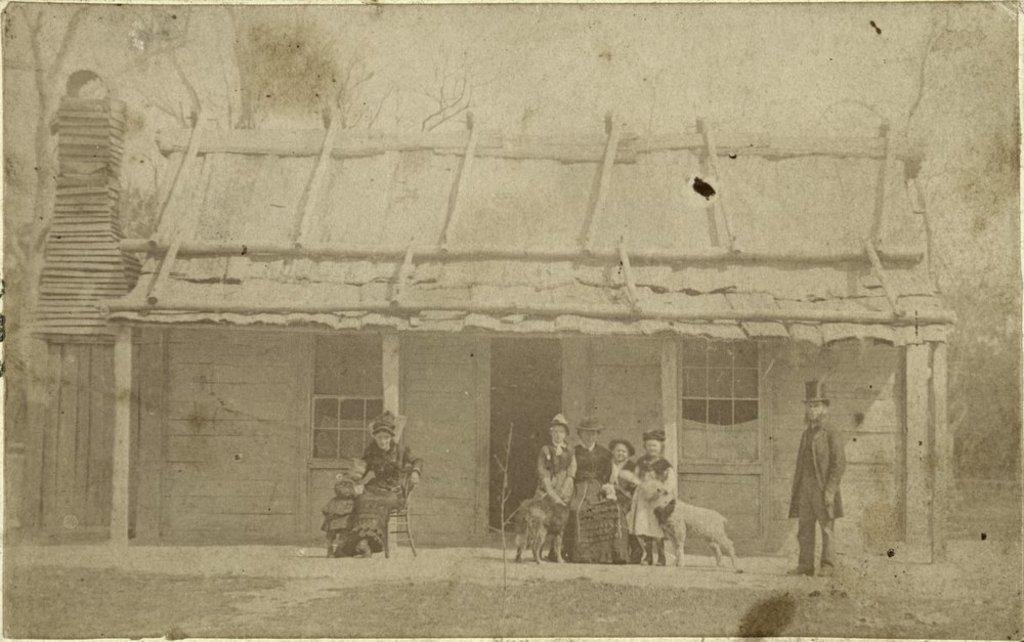How would you summarize this image in a sentence or two? This is a black and white image. The picture is taken near a house. In the center of the picture there are people and dogs, in front of the house. In the center there is a house. In the background there are trees. It is sunny. 